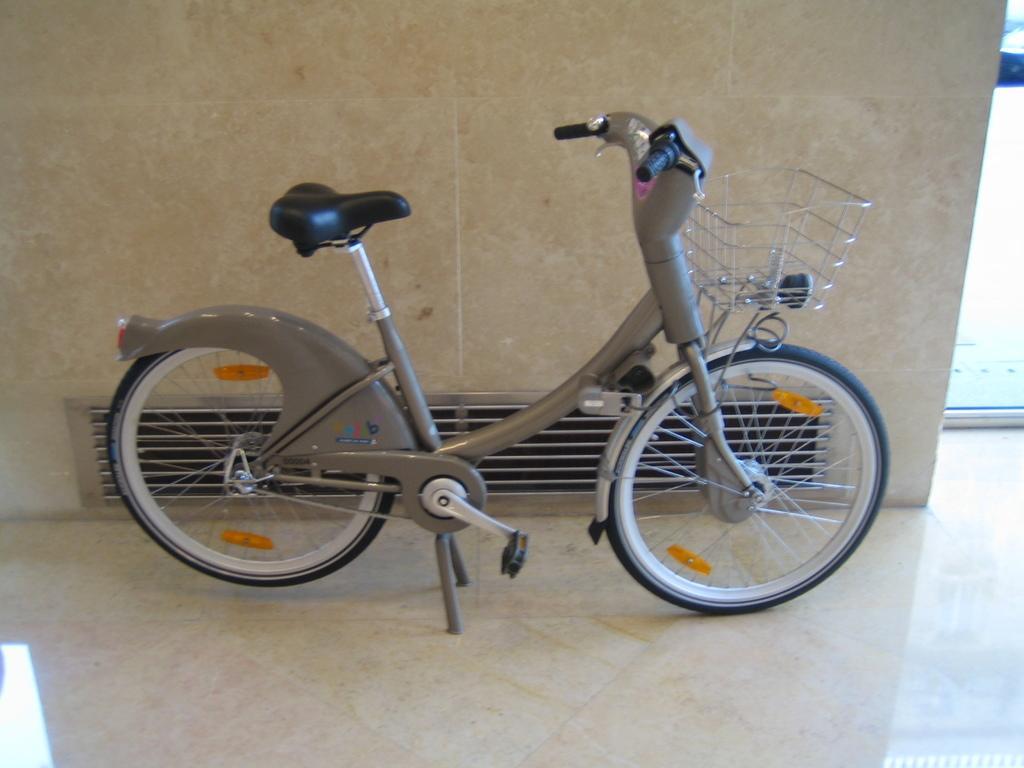Could you give a brief overview of what you see in this image? In this image we can see a bicycle on the floor and also we can see the wall. 